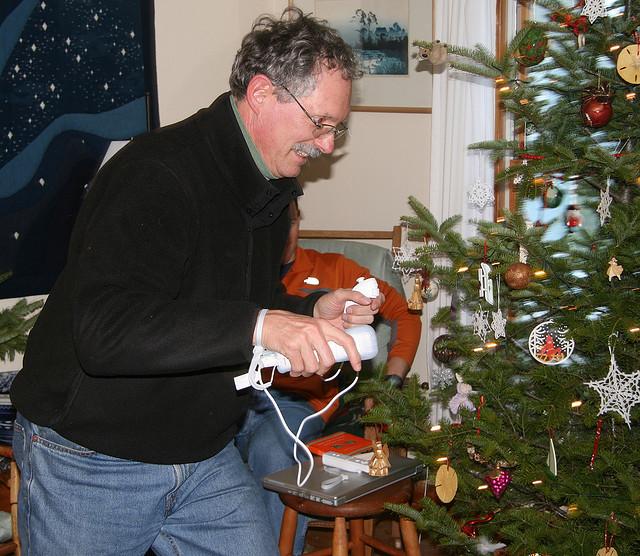Is this man trying to cut up the Christmas tree?
Be succinct. No. What is the man playing with?
Give a very brief answer. Wii. What type of tree is in this photo?
Write a very short answer. Christmas. 